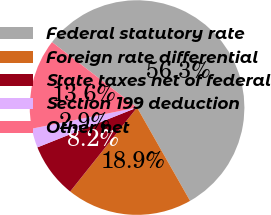Convert chart to OTSL. <chart><loc_0><loc_0><loc_500><loc_500><pie_chart><fcel>Federal statutory rate<fcel>Foreign rate differential<fcel>State taxes net of federal<fcel>Section 199 deduction<fcel>Other net<nl><fcel>56.34%<fcel>18.93%<fcel>8.24%<fcel>2.9%<fcel>13.59%<nl></chart> 